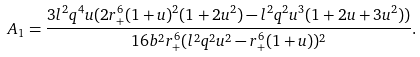Convert formula to latex. <formula><loc_0><loc_0><loc_500><loc_500>A _ { 1 } = \frac { 3 l ^ { 2 } q ^ { 4 } u ( 2 r _ { + } ^ { 6 } ( 1 + u ) ^ { 2 } ( 1 + 2 u ^ { 2 } ) - l ^ { 2 } q ^ { 2 } u ^ { 3 } ( 1 + 2 u + 3 u ^ { 2 } ) ) } { 1 6 b ^ { 2 } r _ { + } ^ { 6 } ( l ^ { 2 } q ^ { 2 } u ^ { 2 } - r _ { + } ^ { 6 } ( 1 + u ) ) ^ { 2 } } .</formula> 